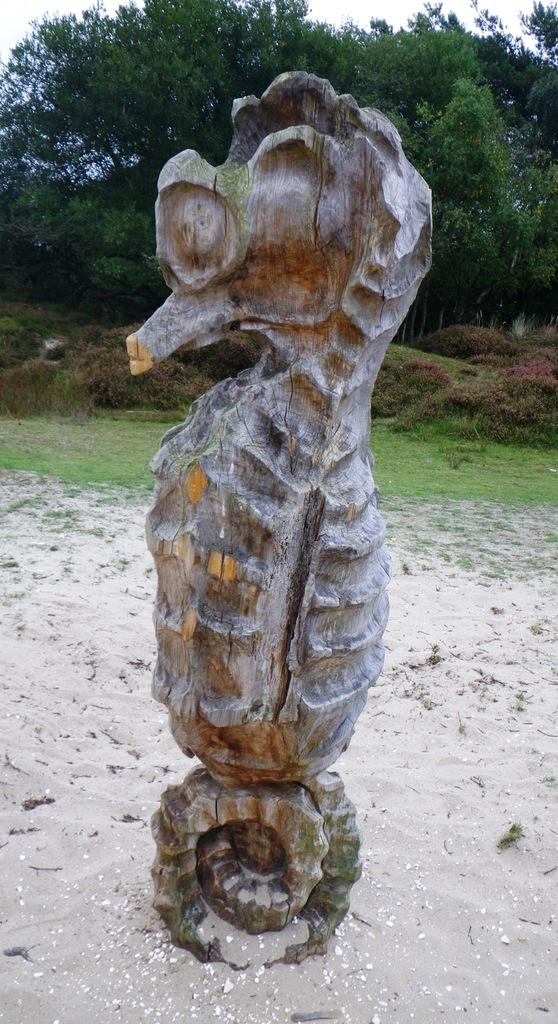What is the main subject of the picture? There is a sculpture in the picture. What can be seen in the background of the picture? There are trees, grass, and the sky visible in the background of the picture. What type of tax is being discussed in the picture? There is no discussion of taxes in the picture; it features a sculpture and a background with trees, grass, and the sky. Can you see a woman in the picture? There is no woman present in the picture; it features a sculpture and a background with trees, grass, and the sky. 